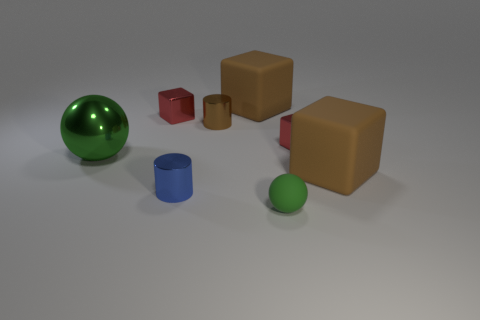Subtract all cyan cubes. Subtract all blue cylinders. How many cubes are left? 4 Add 1 small cyan rubber cylinders. How many objects exist? 9 Subtract all spheres. How many objects are left? 6 Add 2 blue cylinders. How many blue cylinders are left? 3 Add 7 red metallic things. How many red metallic things exist? 9 Subtract 2 green spheres. How many objects are left? 6 Subtract all small purple blocks. Subtract all tiny brown metal cylinders. How many objects are left? 7 